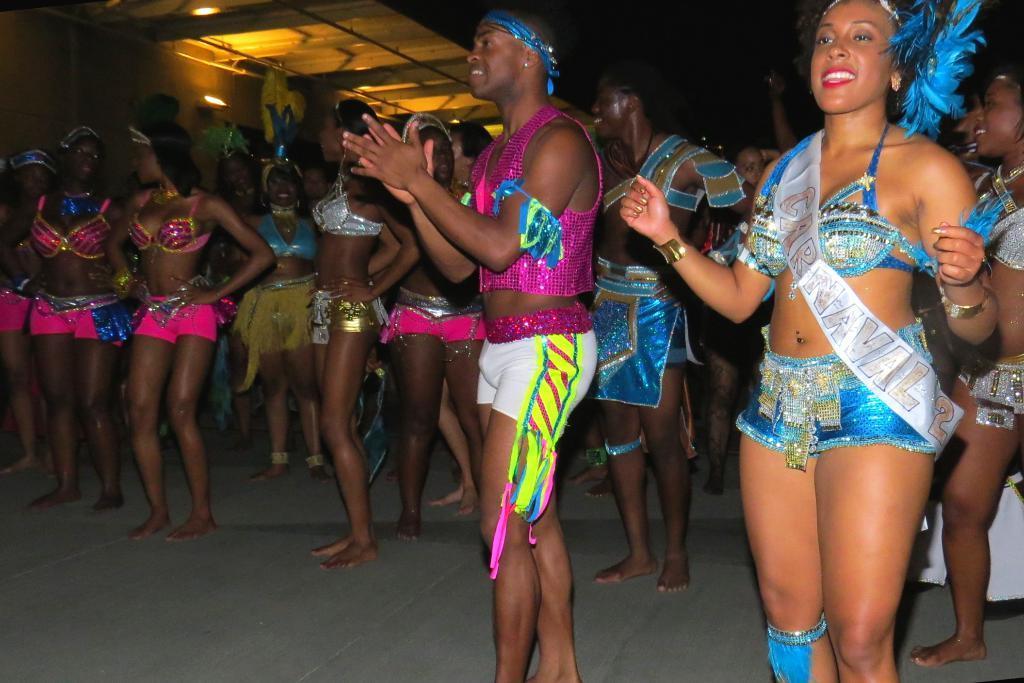Can you describe this image briefly? This picture is clicked inside. In the center we can see the group of men and women standing on the ground and seems to be dancing. At the top there is a roof and we can see the ceiling lights. 